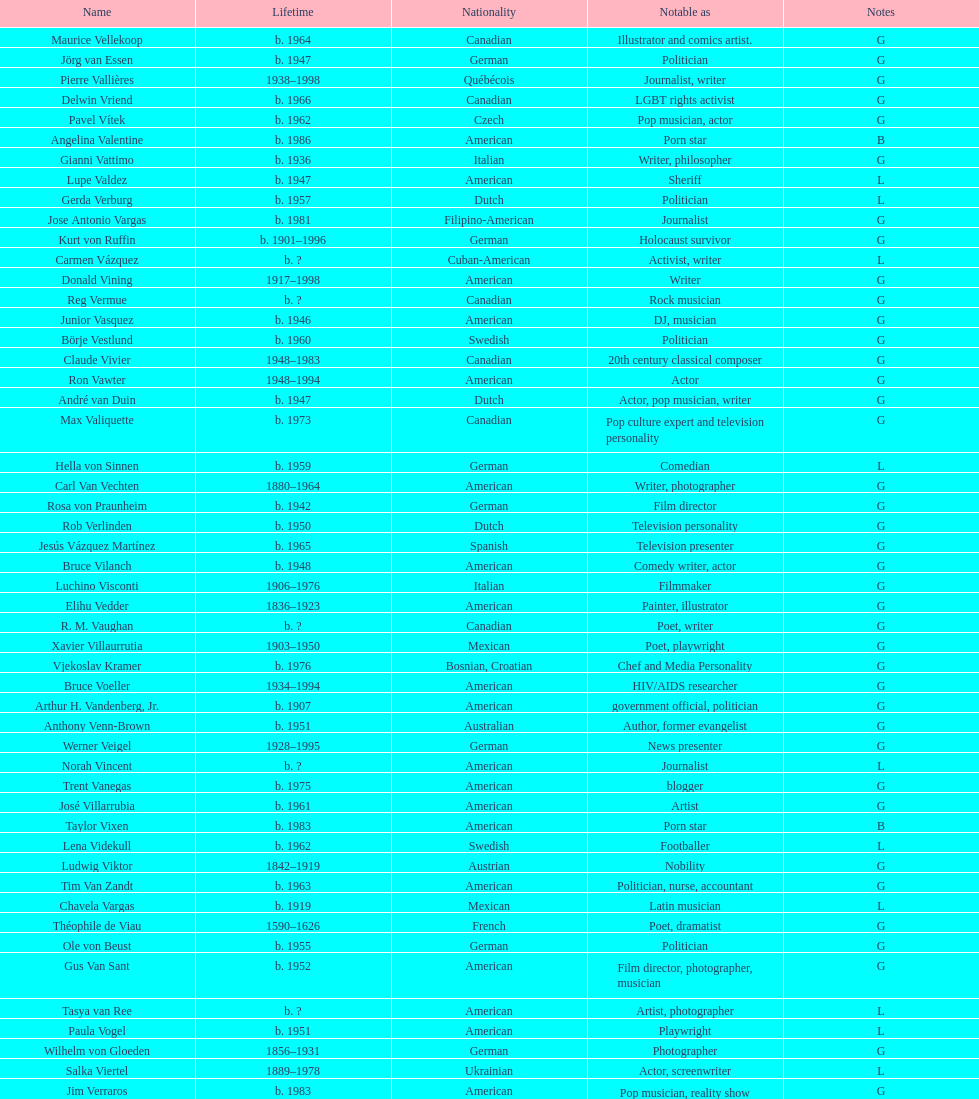What is the number of individuals in this group who were indian? 1. 